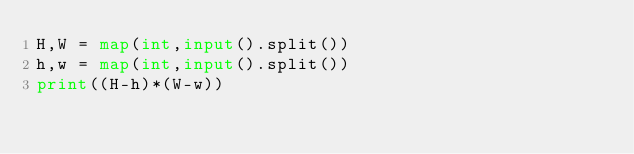Convert code to text. <code><loc_0><loc_0><loc_500><loc_500><_Python_>H,W = map(int,input().split())
h,w = map(int,input().split())
print((H-h)*(W-w))</code> 